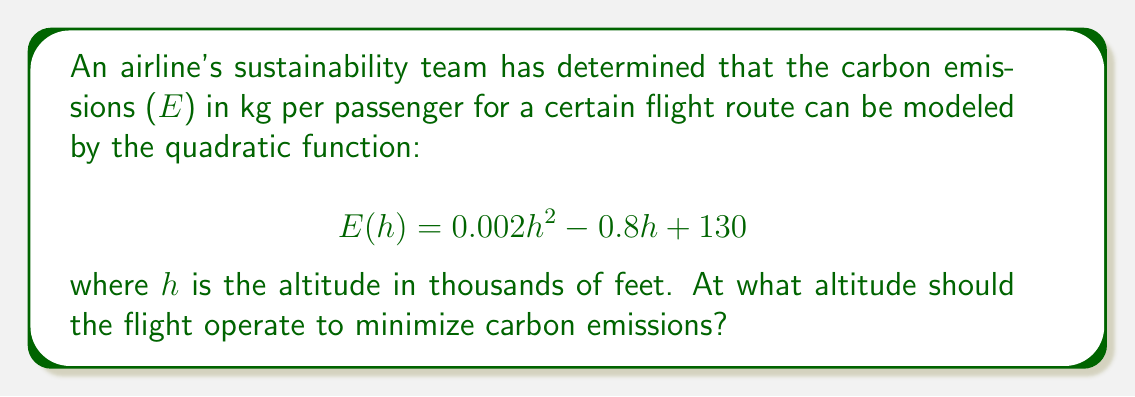Provide a solution to this math problem. To find the altitude that minimizes carbon emissions, we need to find the vertex of the parabola represented by the quadratic function. The vertex represents the minimum point of the parabola since the coefficient of $h^2$ is positive (0.002 > 0).

Step 1: Identify the quadratic function in standard form
$$E(h) = 0.002h^2 - 0.8h + 130$$
This is in the form $f(x) = ax^2 + bx + c$, where:
$a = 0.002$
$b = -0.8$
$c = 130$

Step 2: Use the formula for the h-coordinate of the vertex
The h-coordinate of the vertex is given by $h = -\frac{b}{2a}$

$$h = -\frac{-0.8}{2(0.002)} = \frac{0.8}{0.004} = 200$$

Step 3: Interpret the result
The optimal altitude is 200 thousand feet, or 200,000 feet.

To verify this is a minimum, we can check that $a > 0$, which it is (0.002 > 0).
Answer: 200,000 feet 